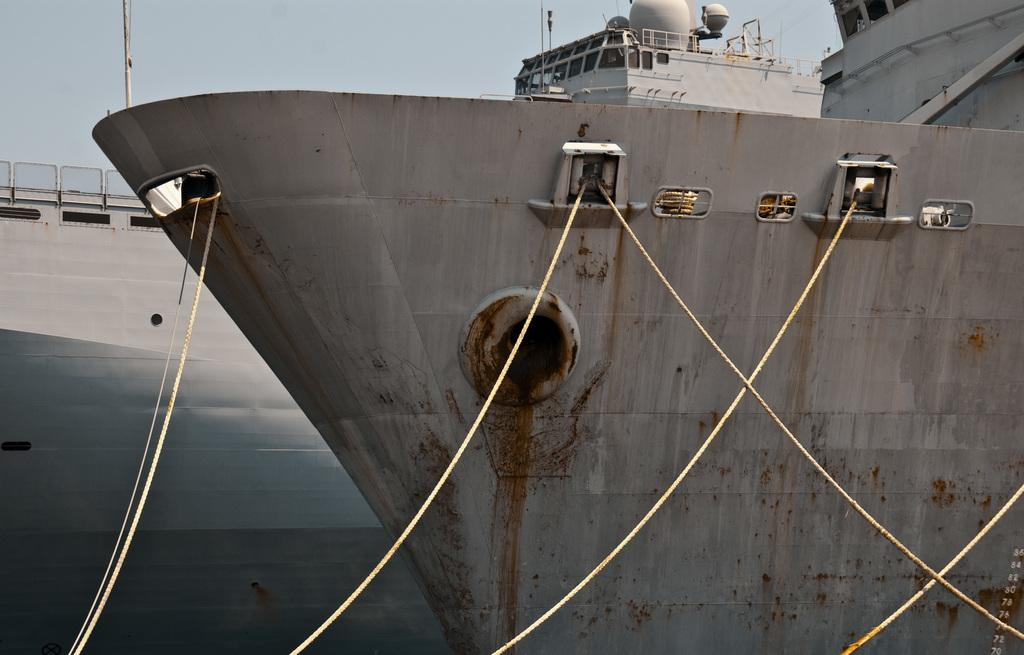What is the main subject of the image? The main subject of the image is a ship. How is the ship secured in the image? The ship is tied with ropes. What is visible at the top of the image? The sky is visible at the top of the image. Where is the fire located in the image? There is no fire present in the image. What unit is being used to measure the distance between the ship and the shore in the image? There is no measurement of distance provided in the image. 